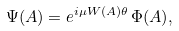<formula> <loc_0><loc_0><loc_500><loc_500>\Psi ( A ) = e ^ { i \mu W ( A ) \theta } \, \Phi ( A ) ,</formula> 